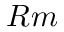Convert formula to latex. <formula><loc_0><loc_0><loc_500><loc_500>R m</formula> 